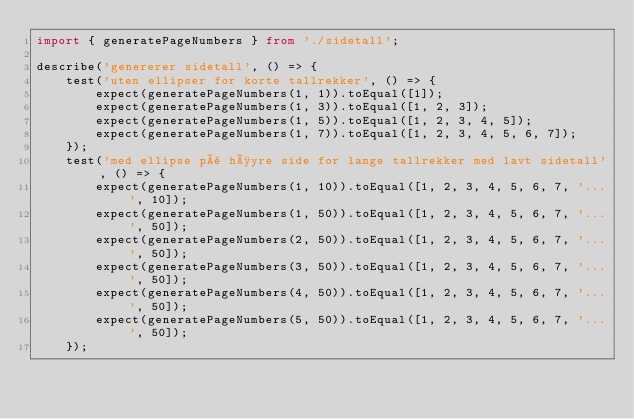Convert code to text. <code><loc_0><loc_0><loc_500><loc_500><_TypeScript_>import { generatePageNumbers } from './sidetall';

describe('genererer sidetall', () => {
    test('uten ellipser for korte tallrekker', () => {
        expect(generatePageNumbers(1, 1)).toEqual([1]);
        expect(generatePageNumbers(1, 3)).toEqual([1, 2, 3]);
        expect(generatePageNumbers(1, 5)).toEqual([1, 2, 3, 4, 5]);
        expect(generatePageNumbers(1, 7)).toEqual([1, 2, 3, 4, 5, 6, 7]);
    });
    test('med ellipse på høyre side for lange tallrekker med lavt sidetall', () => {
        expect(generatePageNumbers(1, 10)).toEqual([1, 2, 3, 4, 5, 6, 7, '...', 10]);
        expect(generatePageNumbers(1, 50)).toEqual([1, 2, 3, 4, 5, 6, 7, '...', 50]);
        expect(generatePageNumbers(2, 50)).toEqual([1, 2, 3, 4, 5, 6, 7, '...', 50]);
        expect(generatePageNumbers(3, 50)).toEqual([1, 2, 3, 4, 5, 6, 7, '...', 50]);
        expect(generatePageNumbers(4, 50)).toEqual([1, 2, 3, 4, 5, 6, 7, '...', 50]);
        expect(generatePageNumbers(5, 50)).toEqual([1, 2, 3, 4, 5, 6, 7, '...', 50]);
    });</code> 